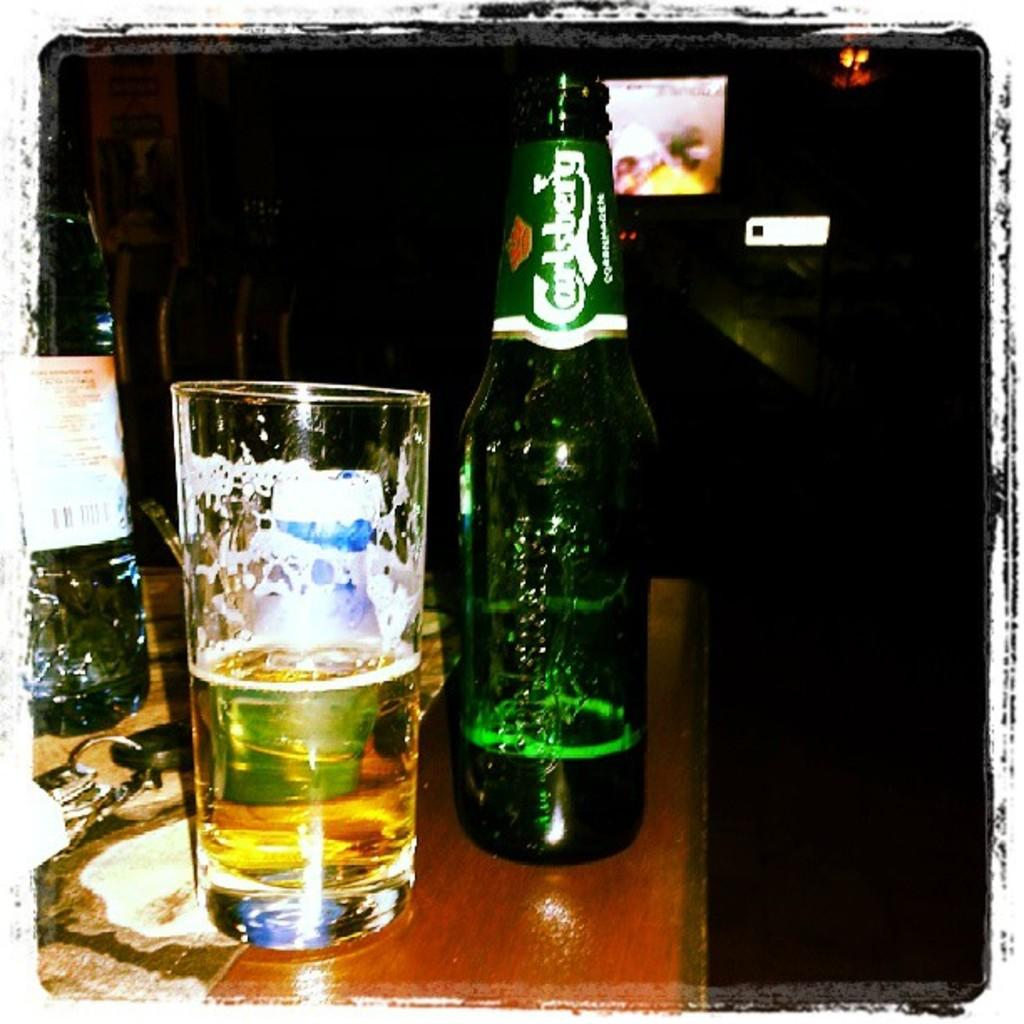<image>
Write a terse but informative summary of the picture. a glass and almost empty bottle of Carlsberg beer 